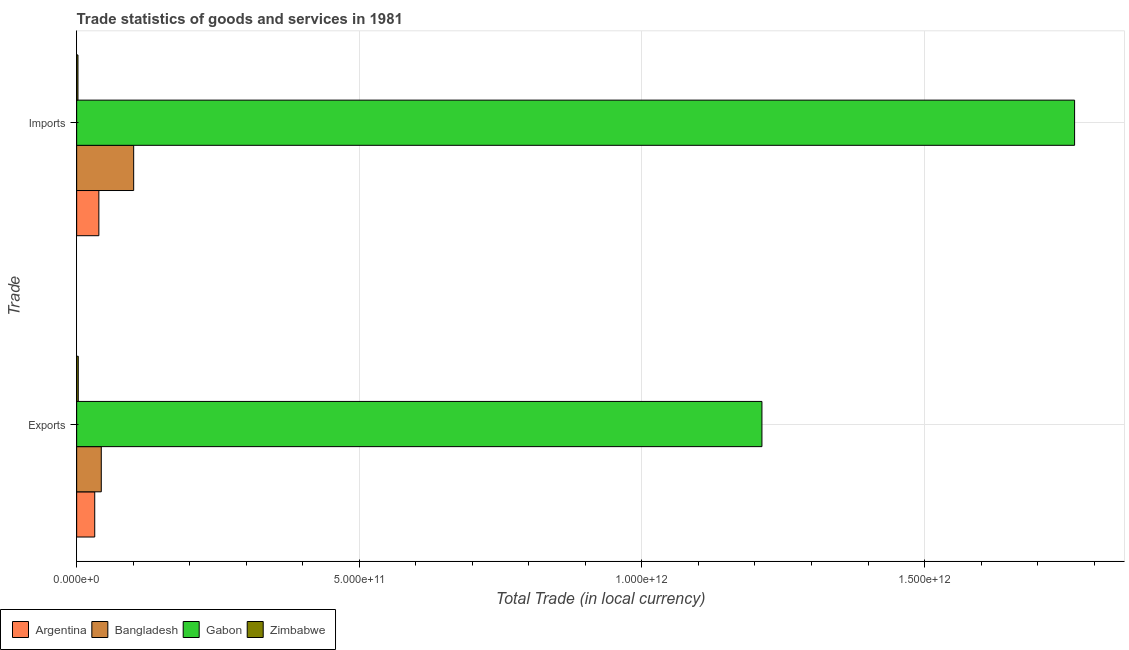Are the number of bars per tick equal to the number of legend labels?
Provide a short and direct response. Yes. How many bars are there on the 1st tick from the bottom?
Your answer should be compact. 4. What is the label of the 2nd group of bars from the top?
Your answer should be compact. Exports. What is the imports of goods and services in Bangladesh?
Give a very brief answer. 1.01e+11. Across all countries, what is the maximum imports of goods and services?
Keep it short and to the point. 1.77e+12. Across all countries, what is the minimum export of goods and services?
Offer a very short reply. 2.85e+09. In which country was the export of goods and services maximum?
Your response must be concise. Gabon. In which country was the export of goods and services minimum?
Your answer should be compact. Zimbabwe. What is the total export of goods and services in the graph?
Make the answer very short. 1.29e+12. What is the difference between the export of goods and services in Argentina and that in Zimbabwe?
Give a very brief answer. 2.91e+1. What is the difference between the export of goods and services in Gabon and the imports of goods and services in Bangladesh?
Offer a very short reply. 1.11e+12. What is the average imports of goods and services per country?
Offer a very short reply. 4.77e+11. What is the difference between the export of goods and services and imports of goods and services in Argentina?
Your response must be concise. -7.31e+09. In how many countries, is the imports of goods and services greater than 1300000000000 LCU?
Provide a succinct answer. 1. What is the ratio of the export of goods and services in Gabon to that in Bangladesh?
Ensure brevity in your answer.  27.83. Is the imports of goods and services in Gabon less than that in Zimbabwe?
Your answer should be compact. No. What does the 4th bar from the bottom in Imports represents?
Offer a very short reply. Zimbabwe. How many bars are there?
Offer a very short reply. 8. Are all the bars in the graph horizontal?
Your response must be concise. Yes. How many countries are there in the graph?
Your response must be concise. 4. What is the difference between two consecutive major ticks on the X-axis?
Give a very brief answer. 5.00e+11. Does the graph contain any zero values?
Your answer should be very brief. No. Does the graph contain grids?
Your response must be concise. Yes. Where does the legend appear in the graph?
Offer a terse response. Bottom left. How many legend labels are there?
Provide a succinct answer. 4. What is the title of the graph?
Offer a very short reply. Trade statistics of goods and services in 1981. What is the label or title of the X-axis?
Offer a very short reply. Total Trade (in local currency). What is the label or title of the Y-axis?
Offer a very short reply. Trade. What is the Total Trade (in local currency) in Argentina in Exports?
Your response must be concise. 3.20e+1. What is the Total Trade (in local currency) in Bangladesh in Exports?
Your response must be concise. 4.36e+1. What is the Total Trade (in local currency) of Gabon in Exports?
Provide a succinct answer. 1.21e+12. What is the Total Trade (in local currency) in Zimbabwe in Exports?
Your response must be concise. 2.85e+09. What is the Total Trade (in local currency) in Argentina in Imports?
Provide a succinct answer. 3.93e+1. What is the Total Trade (in local currency) of Bangladesh in Imports?
Provide a succinct answer. 1.01e+11. What is the Total Trade (in local currency) of Gabon in Imports?
Offer a very short reply. 1.77e+12. What is the Total Trade (in local currency) in Zimbabwe in Imports?
Provide a short and direct response. 2.32e+09. Across all Trade, what is the maximum Total Trade (in local currency) in Argentina?
Offer a very short reply. 3.93e+1. Across all Trade, what is the maximum Total Trade (in local currency) of Bangladesh?
Give a very brief answer. 1.01e+11. Across all Trade, what is the maximum Total Trade (in local currency) in Gabon?
Your response must be concise. 1.77e+12. Across all Trade, what is the maximum Total Trade (in local currency) of Zimbabwe?
Make the answer very short. 2.85e+09. Across all Trade, what is the minimum Total Trade (in local currency) of Argentina?
Ensure brevity in your answer.  3.20e+1. Across all Trade, what is the minimum Total Trade (in local currency) in Bangladesh?
Give a very brief answer. 4.36e+1. Across all Trade, what is the minimum Total Trade (in local currency) in Gabon?
Your response must be concise. 1.21e+12. Across all Trade, what is the minimum Total Trade (in local currency) of Zimbabwe?
Your response must be concise. 2.32e+09. What is the total Total Trade (in local currency) of Argentina in the graph?
Provide a succinct answer. 7.12e+1. What is the total Total Trade (in local currency) in Bangladesh in the graph?
Offer a very short reply. 1.44e+11. What is the total Total Trade (in local currency) of Gabon in the graph?
Give a very brief answer. 2.98e+12. What is the total Total Trade (in local currency) in Zimbabwe in the graph?
Provide a succinct answer. 5.17e+09. What is the difference between the Total Trade (in local currency) in Argentina in Exports and that in Imports?
Offer a very short reply. -7.31e+09. What is the difference between the Total Trade (in local currency) in Bangladesh in Exports and that in Imports?
Ensure brevity in your answer.  -5.73e+1. What is the difference between the Total Trade (in local currency) in Gabon in Exports and that in Imports?
Provide a short and direct response. -5.53e+11. What is the difference between the Total Trade (in local currency) of Zimbabwe in Exports and that in Imports?
Give a very brief answer. 5.34e+08. What is the difference between the Total Trade (in local currency) in Argentina in Exports and the Total Trade (in local currency) in Bangladesh in Imports?
Your answer should be compact. -6.89e+1. What is the difference between the Total Trade (in local currency) in Argentina in Exports and the Total Trade (in local currency) in Gabon in Imports?
Offer a very short reply. -1.73e+12. What is the difference between the Total Trade (in local currency) of Argentina in Exports and the Total Trade (in local currency) of Zimbabwe in Imports?
Ensure brevity in your answer.  2.96e+1. What is the difference between the Total Trade (in local currency) in Bangladesh in Exports and the Total Trade (in local currency) in Gabon in Imports?
Your answer should be compact. -1.72e+12. What is the difference between the Total Trade (in local currency) of Bangladesh in Exports and the Total Trade (in local currency) of Zimbabwe in Imports?
Your answer should be very brief. 4.12e+1. What is the difference between the Total Trade (in local currency) in Gabon in Exports and the Total Trade (in local currency) in Zimbabwe in Imports?
Offer a very short reply. 1.21e+12. What is the average Total Trade (in local currency) in Argentina per Trade?
Offer a very short reply. 3.56e+1. What is the average Total Trade (in local currency) of Bangladesh per Trade?
Offer a very short reply. 7.22e+1. What is the average Total Trade (in local currency) of Gabon per Trade?
Make the answer very short. 1.49e+12. What is the average Total Trade (in local currency) of Zimbabwe per Trade?
Offer a very short reply. 2.59e+09. What is the difference between the Total Trade (in local currency) of Argentina and Total Trade (in local currency) of Bangladesh in Exports?
Give a very brief answer. -1.16e+1. What is the difference between the Total Trade (in local currency) of Argentina and Total Trade (in local currency) of Gabon in Exports?
Keep it short and to the point. -1.18e+12. What is the difference between the Total Trade (in local currency) in Argentina and Total Trade (in local currency) in Zimbabwe in Exports?
Your answer should be compact. 2.91e+1. What is the difference between the Total Trade (in local currency) in Bangladesh and Total Trade (in local currency) in Gabon in Exports?
Provide a succinct answer. -1.17e+12. What is the difference between the Total Trade (in local currency) of Bangladesh and Total Trade (in local currency) of Zimbabwe in Exports?
Offer a very short reply. 4.07e+1. What is the difference between the Total Trade (in local currency) in Gabon and Total Trade (in local currency) in Zimbabwe in Exports?
Your response must be concise. 1.21e+12. What is the difference between the Total Trade (in local currency) of Argentina and Total Trade (in local currency) of Bangladesh in Imports?
Your answer should be compact. -6.16e+1. What is the difference between the Total Trade (in local currency) of Argentina and Total Trade (in local currency) of Gabon in Imports?
Your response must be concise. -1.73e+12. What is the difference between the Total Trade (in local currency) in Argentina and Total Trade (in local currency) in Zimbabwe in Imports?
Your answer should be very brief. 3.70e+1. What is the difference between the Total Trade (in local currency) in Bangladesh and Total Trade (in local currency) in Gabon in Imports?
Provide a succinct answer. -1.66e+12. What is the difference between the Total Trade (in local currency) of Bangladesh and Total Trade (in local currency) of Zimbabwe in Imports?
Offer a very short reply. 9.85e+1. What is the difference between the Total Trade (in local currency) of Gabon and Total Trade (in local currency) of Zimbabwe in Imports?
Ensure brevity in your answer.  1.76e+12. What is the ratio of the Total Trade (in local currency) in Argentina in Exports to that in Imports?
Give a very brief answer. 0.81. What is the ratio of the Total Trade (in local currency) of Bangladesh in Exports to that in Imports?
Offer a terse response. 0.43. What is the ratio of the Total Trade (in local currency) in Gabon in Exports to that in Imports?
Your answer should be very brief. 0.69. What is the ratio of the Total Trade (in local currency) of Zimbabwe in Exports to that in Imports?
Make the answer very short. 1.23. What is the difference between the highest and the second highest Total Trade (in local currency) of Argentina?
Provide a short and direct response. 7.31e+09. What is the difference between the highest and the second highest Total Trade (in local currency) of Bangladesh?
Your response must be concise. 5.73e+1. What is the difference between the highest and the second highest Total Trade (in local currency) of Gabon?
Provide a succinct answer. 5.53e+11. What is the difference between the highest and the second highest Total Trade (in local currency) of Zimbabwe?
Your answer should be compact. 5.34e+08. What is the difference between the highest and the lowest Total Trade (in local currency) in Argentina?
Ensure brevity in your answer.  7.31e+09. What is the difference between the highest and the lowest Total Trade (in local currency) of Bangladesh?
Your answer should be very brief. 5.73e+1. What is the difference between the highest and the lowest Total Trade (in local currency) of Gabon?
Provide a short and direct response. 5.53e+11. What is the difference between the highest and the lowest Total Trade (in local currency) in Zimbabwe?
Your answer should be very brief. 5.34e+08. 